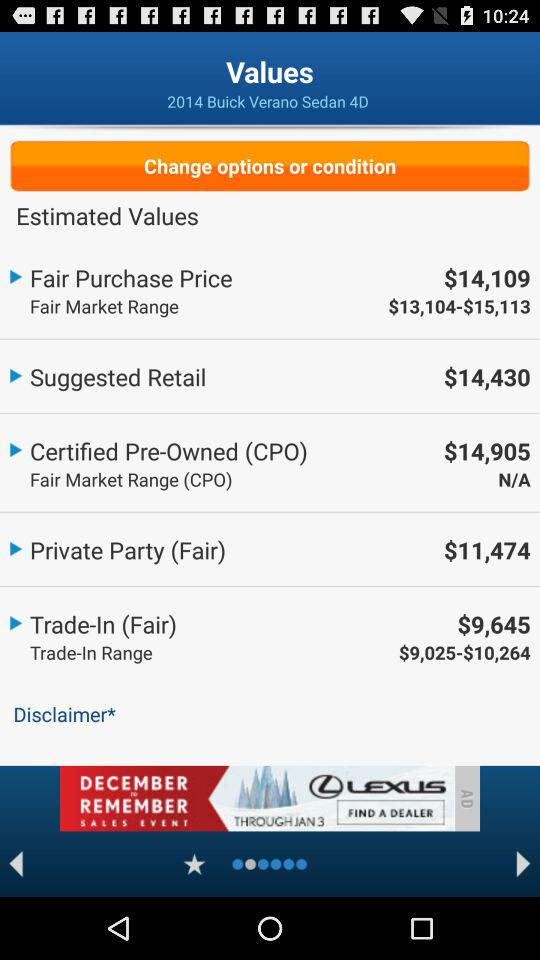What is the difference between the Fair Purchase Price and the Suggested Retail values?
Answer the question using a single word or phrase. $321 